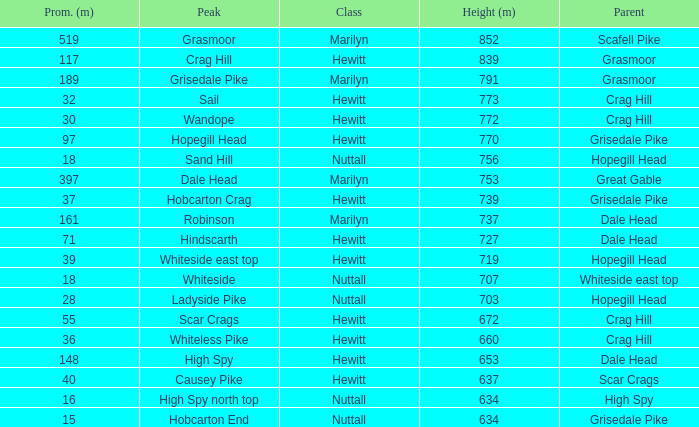Which Parent has height smaller than 756 and a Prom of 39? Hopegill Head. 